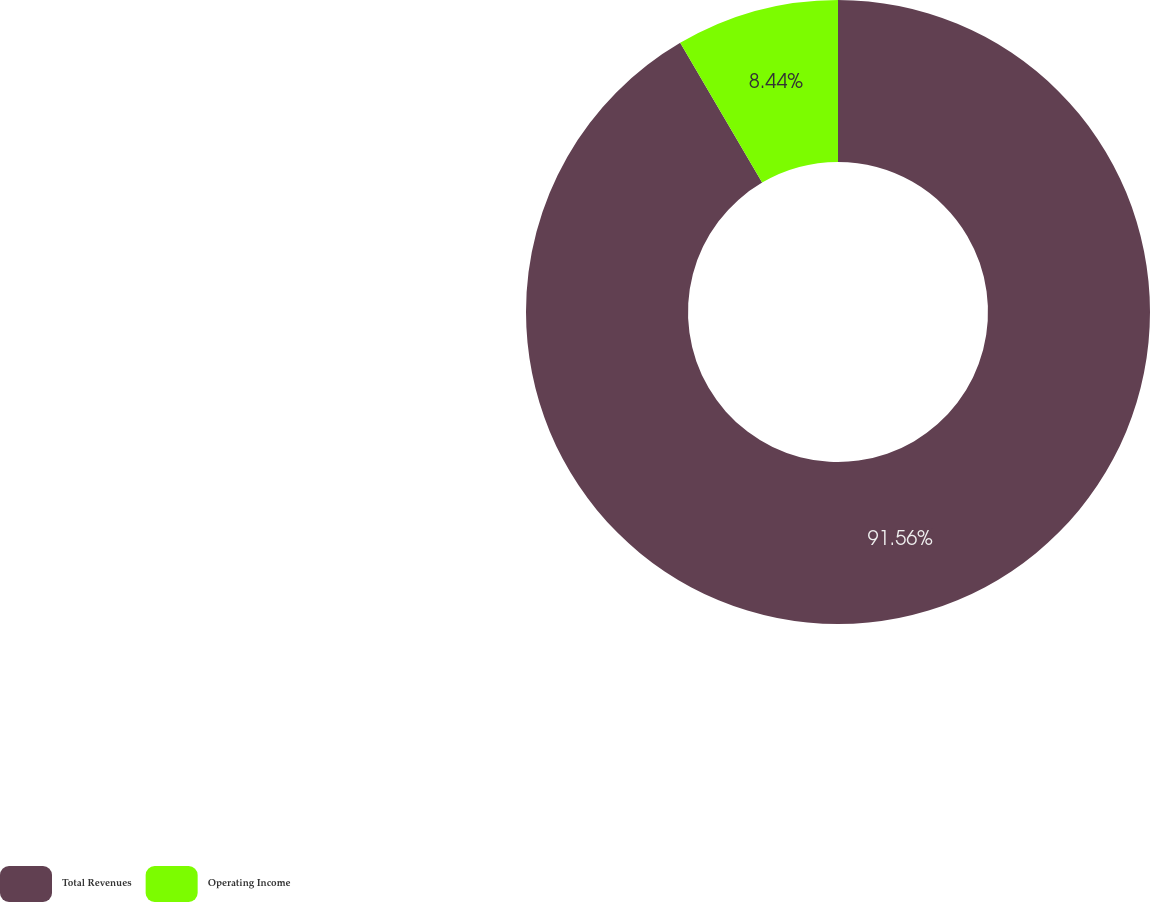Convert chart. <chart><loc_0><loc_0><loc_500><loc_500><pie_chart><fcel>Total Revenues<fcel>Operating Income<nl><fcel>91.56%<fcel>8.44%<nl></chart> 